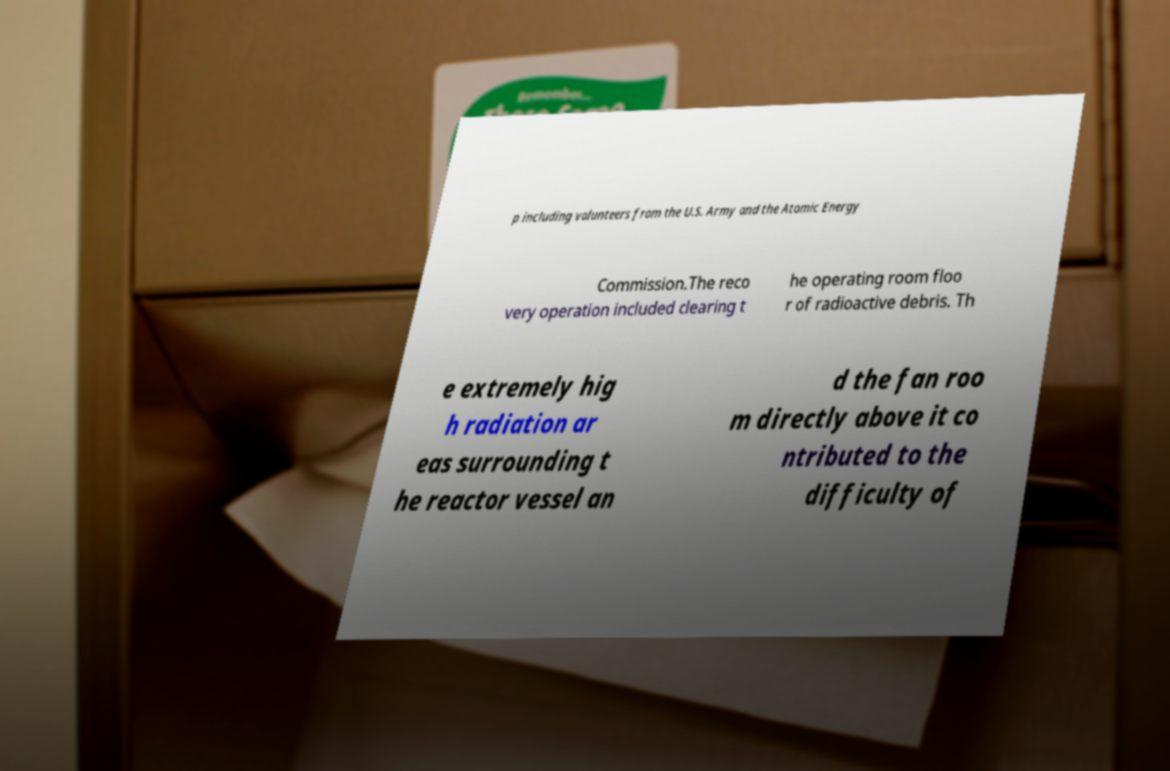Could you assist in decoding the text presented in this image and type it out clearly? p including volunteers from the U.S. Army and the Atomic Energy Commission.The reco very operation included clearing t he operating room floo r of radioactive debris. Th e extremely hig h radiation ar eas surrounding t he reactor vessel an d the fan roo m directly above it co ntributed to the difficulty of 